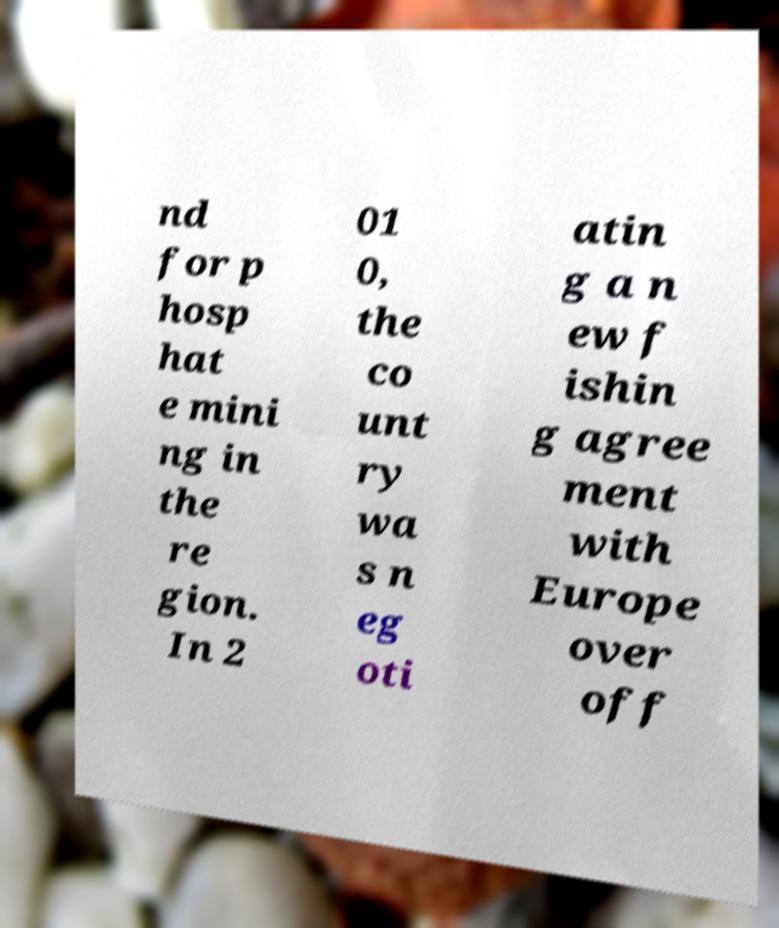Can you read and provide the text displayed in the image?This photo seems to have some interesting text. Can you extract and type it out for me? nd for p hosp hat e mini ng in the re gion. In 2 01 0, the co unt ry wa s n eg oti atin g a n ew f ishin g agree ment with Europe over off 